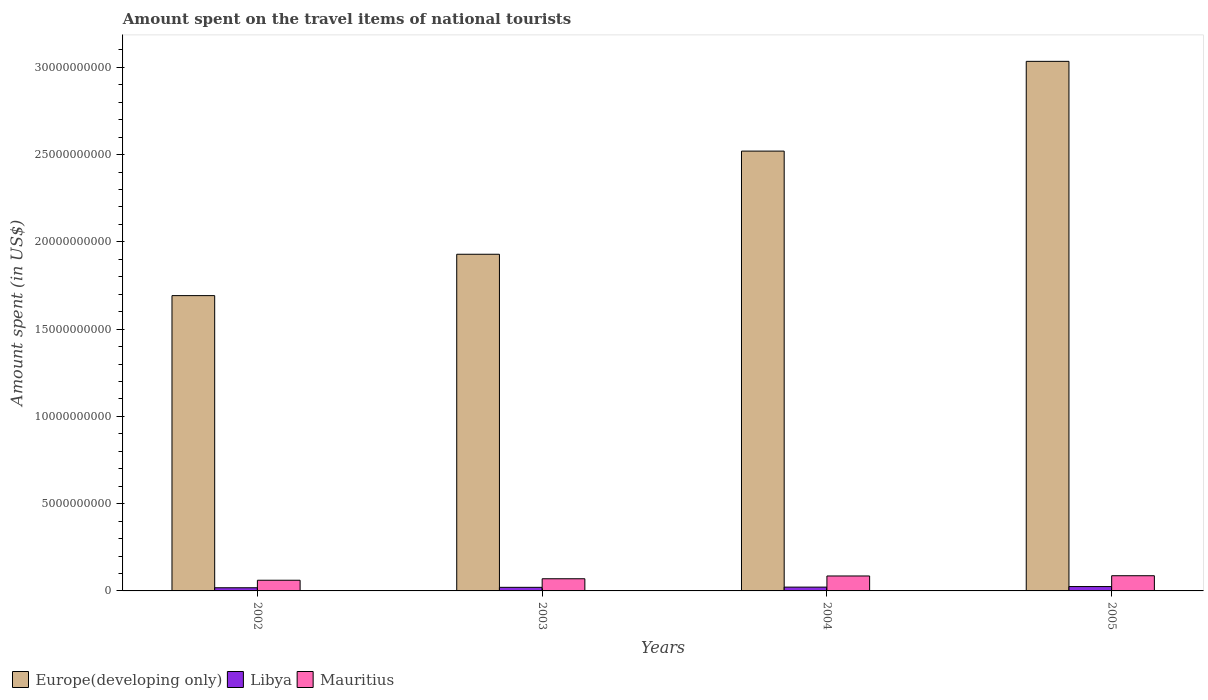How many different coloured bars are there?
Provide a succinct answer. 3. How many groups of bars are there?
Your response must be concise. 4. How many bars are there on the 4th tick from the right?
Provide a succinct answer. 3. What is the label of the 4th group of bars from the left?
Your answer should be compact. 2005. In how many cases, is the number of bars for a given year not equal to the number of legend labels?
Provide a succinct answer. 0. What is the amount spent on the travel items of national tourists in Europe(developing only) in 2002?
Your response must be concise. 1.69e+1. Across all years, what is the maximum amount spent on the travel items of national tourists in Libya?
Your answer should be compact. 2.50e+08. Across all years, what is the minimum amount spent on the travel items of national tourists in Europe(developing only)?
Give a very brief answer. 1.69e+1. In which year was the amount spent on the travel items of national tourists in Europe(developing only) maximum?
Keep it short and to the point. 2005. What is the total amount spent on the travel items of national tourists in Libya in the graph?
Provide a succinct answer. 8.54e+08. What is the difference between the amount spent on the travel items of national tourists in Libya in 2002 and that in 2003?
Offer a terse response. -2.40e+07. What is the difference between the amount spent on the travel items of national tourists in Libya in 2003 and the amount spent on the travel items of national tourists in Europe(developing only) in 2005?
Your answer should be compact. -3.01e+1. What is the average amount spent on the travel items of national tourists in Mauritius per year?
Provide a short and direct response. 7.59e+08. In the year 2003, what is the difference between the amount spent on the travel items of national tourists in Mauritius and amount spent on the travel items of national tourists in Libya?
Make the answer very short. 4.92e+08. What is the ratio of the amount spent on the travel items of national tourists in Libya in 2003 to that in 2005?
Keep it short and to the point. 0.82. Is the amount spent on the travel items of national tourists in Mauritius in 2003 less than that in 2004?
Provide a short and direct response. Yes. Is the difference between the amount spent on the travel items of national tourists in Mauritius in 2002 and 2005 greater than the difference between the amount spent on the travel items of national tourists in Libya in 2002 and 2005?
Your response must be concise. No. What is the difference between the highest and the second highest amount spent on the travel items of national tourists in Mauritius?
Provide a succinct answer. 1.50e+07. What is the difference between the highest and the lowest amount spent on the travel items of national tourists in Europe(developing only)?
Give a very brief answer. 1.34e+1. In how many years, is the amount spent on the travel items of national tourists in Mauritius greater than the average amount spent on the travel items of national tourists in Mauritius taken over all years?
Provide a succinct answer. 2. What does the 1st bar from the left in 2004 represents?
Offer a terse response. Europe(developing only). What does the 3rd bar from the right in 2002 represents?
Make the answer very short. Europe(developing only). Is it the case that in every year, the sum of the amount spent on the travel items of national tourists in Mauritius and amount spent on the travel items of national tourists in Libya is greater than the amount spent on the travel items of national tourists in Europe(developing only)?
Offer a terse response. No. How many bars are there?
Ensure brevity in your answer.  12. How many years are there in the graph?
Your answer should be compact. 4. Are the values on the major ticks of Y-axis written in scientific E-notation?
Offer a terse response. No. How many legend labels are there?
Offer a very short reply. 3. What is the title of the graph?
Ensure brevity in your answer.  Amount spent on the travel items of national tourists. What is the label or title of the X-axis?
Your response must be concise. Years. What is the label or title of the Y-axis?
Offer a terse response. Amount spent (in US$). What is the Amount spent (in US$) in Europe(developing only) in 2002?
Provide a succinct answer. 1.69e+1. What is the Amount spent (in US$) of Libya in 2002?
Provide a short and direct response. 1.81e+08. What is the Amount spent (in US$) in Mauritius in 2002?
Ensure brevity in your answer.  6.12e+08. What is the Amount spent (in US$) in Europe(developing only) in 2003?
Your response must be concise. 1.93e+1. What is the Amount spent (in US$) of Libya in 2003?
Give a very brief answer. 2.05e+08. What is the Amount spent (in US$) of Mauritius in 2003?
Offer a very short reply. 6.97e+08. What is the Amount spent (in US$) of Europe(developing only) in 2004?
Keep it short and to the point. 2.52e+1. What is the Amount spent (in US$) in Libya in 2004?
Offer a terse response. 2.18e+08. What is the Amount spent (in US$) in Mauritius in 2004?
Make the answer very short. 8.56e+08. What is the Amount spent (in US$) in Europe(developing only) in 2005?
Provide a succinct answer. 3.03e+1. What is the Amount spent (in US$) in Libya in 2005?
Give a very brief answer. 2.50e+08. What is the Amount spent (in US$) in Mauritius in 2005?
Ensure brevity in your answer.  8.71e+08. Across all years, what is the maximum Amount spent (in US$) in Europe(developing only)?
Offer a very short reply. 3.03e+1. Across all years, what is the maximum Amount spent (in US$) in Libya?
Offer a terse response. 2.50e+08. Across all years, what is the maximum Amount spent (in US$) of Mauritius?
Offer a very short reply. 8.71e+08. Across all years, what is the minimum Amount spent (in US$) of Europe(developing only)?
Your response must be concise. 1.69e+1. Across all years, what is the minimum Amount spent (in US$) in Libya?
Make the answer very short. 1.81e+08. Across all years, what is the minimum Amount spent (in US$) of Mauritius?
Provide a short and direct response. 6.12e+08. What is the total Amount spent (in US$) of Europe(developing only) in the graph?
Provide a succinct answer. 9.18e+1. What is the total Amount spent (in US$) of Libya in the graph?
Give a very brief answer. 8.54e+08. What is the total Amount spent (in US$) in Mauritius in the graph?
Offer a terse response. 3.04e+09. What is the difference between the Amount spent (in US$) of Europe(developing only) in 2002 and that in 2003?
Give a very brief answer. -2.37e+09. What is the difference between the Amount spent (in US$) in Libya in 2002 and that in 2003?
Provide a succinct answer. -2.40e+07. What is the difference between the Amount spent (in US$) in Mauritius in 2002 and that in 2003?
Provide a succinct answer. -8.50e+07. What is the difference between the Amount spent (in US$) in Europe(developing only) in 2002 and that in 2004?
Ensure brevity in your answer.  -8.28e+09. What is the difference between the Amount spent (in US$) in Libya in 2002 and that in 2004?
Ensure brevity in your answer.  -3.70e+07. What is the difference between the Amount spent (in US$) in Mauritius in 2002 and that in 2004?
Ensure brevity in your answer.  -2.44e+08. What is the difference between the Amount spent (in US$) in Europe(developing only) in 2002 and that in 2005?
Provide a short and direct response. -1.34e+1. What is the difference between the Amount spent (in US$) of Libya in 2002 and that in 2005?
Your response must be concise. -6.90e+07. What is the difference between the Amount spent (in US$) of Mauritius in 2002 and that in 2005?
Give a very brief answer. -2.59e+08. What is the difference between the Amount spent (in US$) of Europe(developing only) in 2003 and that in 2004?
Give a very brief answer. -5.91e+09. What is the difference between the Amount spent (in US$) of Libya in 2003 and that in 2004?
Offer a terse response. -1.30e+07. What is the difference between the Amount spent (in US$) in Mauritius in 2003 and that in 2004?
Provide a short and direct response. -1.59e+08. What is the difference between the Amount spent (in US$) in Europe(developing only) in 2003 and that in 2005?
Make the answer very short. -1.11e+1. What is the difference between the Amount spent (in US$) in Libya in 2003 and that in 2005?
Offer a very short reply. -4.50e+07. What is the difference between the Amount spent (in US$) in Mauritius in 2003 and that in 2005?
Provide a short and direct response. -1.74e+08. What is the difference between the Amount spent (in US$) in Europe(developing only) in 2004 and that in 2005?
Provide a short and direct response. -5.14e+09. What is the difference between the Amount spent (in US$) in Libya in 2004 and that in 2005?
Keep it short and to the point. -3.20e+07. What is the difference between the Amount spent (in US$) of Mauritius in 2004 and that in 2005?
Your answer should be compact. -1.50e+07. What is the difference between the Amount spent (in US$) of Europe(developing only) in 2002 and the Amount spent (in US$) of Libya in 2003?
Make the answer very short. 1.67e+1. What is the difference between the Amount spent (in US$) of Europe(developing only) in 2002 and the Amount spent (in US$) of Mauritius in 2003?
Provide a succinct answer. 1.62e+1. What is the difference between the Amount spent (in US$) in Libya in 2002 and the Amount spent (in US$) in Mauritius in 2003?
Offer a terse response. -5.16e+08. What is the difference between the Amount spent (in US$) of Europe(developing only) in 2002 and the Amount spent (in US$) of Libya in 2004?
Your response must be concise. 1.67e+1. What is the difference between the Amount spent (in US$) in Europe(developing only) in 2002 and the Amount spent (in US$) in Mauritius in 2004?
Ensure brevity in your answer.  1.61e+1. What is the difference between the Amount spent (in US$) in Libya in 2002 and the Amount spent (in US$) in Mauritius in 2004?
Offer a terse response. -6.75e+08. What is the difference between the Amount spent (in US$) in Europe(developing only) in 2002 and the Amount spent (in US$) in Libya in 2005?
Give a very brief answer. 1.67e+1. What is the difference between the Amount spent (in US$) in Europe(developing only) in 2002 and the Amount spent (in US$) in Mauritius in 2005?
Make the answer very short. 1.60e+1. What is the difference between the Amount spent (in US$) in Libya in 2002 and the Amount spent (in US$) in Mauritius in 2005?
Your answer should be very brief. -6.90e+08. What is the difference between the Amount spent (in US$) of Europe(developing only) in 2003 and the Amount spent (in US$) of Libya in 2004?
Your response must be concise. 1.91e+1. What is the difference between the Amount spent (in US$) of Europe(developing only) in 2003 and the Amount spent (in US$) of Mauritius in 2004?
Make the answer very short. 1.84e+1. What is the difference between the Amount spent (in US$) of Libya in 2003 and the Amount spent (in US$) of Mauritius in 2004?
Provide a short and direct response. -6.51e+08. What is the difference between the Amount spent (in US$) of Europe(developing only) in 2003 and the Amount spent (in US$) of Libya in 2005?
Offer a terse response. 1.90e+1. What is the difference between the Amount spent (in US$) in Europe(developing only) in 2003 and the Amount spent (in US$) in Mauritius in 2005?
Offer a terse response. 1.84e+1. What is the difference between the Amount spent (in US$) in Libya in 2003 and the Amount spent (in US$) in Mauritius in 2005?
Your answer should be very brief. -6.66e+08. What is the difference between the Amount spent (in US$) in Europe(developing only) in 2004 and the Amount spent (in US$) in Libya in 2005?
Your answer should be compact. 2.49e+1. What is the difference between the Amount spent (in US$) of Europe(developing only) in 2004 and the Amount spent (in US$) of Mauritius in 2005?
Give a very brief answer. 2.43e+1. What is the difference between the Amount spent (in US$) in Libya in 2004 and the Amount spent (in US$) in Mauritius in 2005?
Give a very brief answer. -6.53e+08. What is the average Amount spent (in US$) of Europe(developing only) per year?
Provide a short and direct response. 2.29e+1. What is the average Amount spent (in US$) in Libya per year?
Offer a terse response. 2.14e+08. What is the average Amount spent (in US$) in Mauritius per year?
Offer a terse response. 7.59e+08. In the year 2002, what is the difference between the Amount spent (in US$) in Europe(developing only) and Amount spent (in US$) in Libya?
Offer a very short reply. 1.67e+1. In the year 2002, what is the difference between the Amount spent (in US$) in Europe(developing only) and Amount spent (in US$) in Mauritius?
Ensure brevity in your answer.  1.63e+1. In the year 2002, what is the difference between the Amount spent (in US$) of Libya and Amount spent (in US$) of Mauritius?
Ensure brevity in your answer.  -4.31e+08. In the year 2003, what is the difference between the Amount spent (in US$) in Europe(developing only) and Amount spent (in US$) in Libya?
Provide a short and direct response. 1.91e+1. In the year 2003, what is the difference between the Amount spent (in US$) in Europe(developing only) and Amount spent (in US$) in Mauritius?
Provide a short and direct response. 1.86e+1. In the year 2003, what is the difference between the Amount spent (in US$) of Libya and Amount spent (in US$) of Mauritius?
Your answer should be very brief. -4.92e+08. In the year 2004, what is the difference between the Amount spent (in US$) in Europe(developing only) and Amount spent (in US$) in Libya?
Your response must be concise. 2.50e+1. In the year 2004, what is the difference between the Amount spent (in US$) of Europe(developing only) and Amount spent (in US$) of Mauritius?
Ensure brevity in your answer.  2.43e+1. In the year 2004, what is the difference between the Amount spent (in US$) in Libya and Amount spent (in US$) in Mauritius?
Give a very brief answer. -6.38e+08. In the year 2005, what is the difference between the Amount spent (in US$) of Europe(developing only) and Amount spent (in US$) of Libya?
Give a very brief answer. 3.01e+1. In the year 2005, what is the difference between the Amount spent (in US$) in Europe(developing only) and Amount spent (in US$) in Mauritius?
Offer a terse response. 2.95e+1. In the year 2005, what is the difference between the Amount spent (in US$) in Libya and Amount spent (in US$) in Mauritius?
Your answer should be very brief. -6.21e+08. What is the ratio of the Amount spent (in US$) of Europe(developing only) in 2002 to that in 2003?
Your answer should be very brief. 0.88. What is the ratio of the Amount spent (in US$) in Libya in 2002 to that in 2003?
Your answer should be very brief. 0.88. What is the ratio of the Amount spent (in US$) of Mauritius in 2002 to that in 2003?
Offer a terse response. 0.88. What is the ratio of the Amount spent (in US$) of Europe(developing only) in 2002 to that in 2004?
Your answer should be compact. 0.67. What is the ratio of the Amount spent (in US$) of Libya in 2002 to that in 2004?
Offer a very short reply. 0.83. What is the ratio of the Amount spent (in US$) in Mauritius in 2002 to that in 2004?
Your answer should be compact. 0.71. What is the ratio of the Amount spent (in US$) in Europe(developing only) in 2002 to that in 2005?
Your answer should be compact. 0.56. What is the ratio of the Amount spent (in US$) of Libya in 2002 to that in 2005?
Give a very brief answer. 0.72. What is the ratio of the Amount spent (in US$) of Mauritius in 2002 to that in 2005?
Offer a terse response. 0.7. What is the ratio of the Amount spent (in US$) of Europe(developing only) in 2003 to that in 2004?
Keep it short and to the point. 0.77. What is the ratio of the Amount spent (in US$) in Libya in 2003 to that in 2004?
Give a very brief answer. 0.94. What is the ratio of the Amount spent (in US$) of Mauritius in 2003 to that in 2004?
Make the answer very short. 0.81. What is the ratio of the Amount spent (in US$) of Europe(developing only) in 2003 to that in 2005?
Your answer should be very brief. 0.64. What is the ratio of the Amount spent (in US$) of Libya in 2003 to that in 2005?
Your answer should be very brief. 0.82. What is the ratio of the Amount spent (in US$) of Mauritius in 2003 to that in 2005?
Offer a terse response. 0.8. What is the ratio of the Amount spent (in US$) of Europe(developing only) in 2004 to that in 2005?
Make the answer very short. 0.83. What is the ratio of the Amount spent (in US$) in Libya in 2004 to that in 2005?
Offer a terse response. 0.87. What is the ratio of the Amount spent (in US$) of Mauritius in 2004 to that in 2005?
Keep it short and to the point. 0.98. What is the difference between the highest and the second highest Amount spent (in US$) in Europe(developing only)?
Keep it short and to the point. 5.14e+09. What is the difference between the highest and the second highest Amount spent (in US$) of Libya?
Offer a very short reply. 3.20e+07. What is the difference between the highest and the second highest Amount spent (in US$) in Mauritius?
Your answer should be compact. 1.50e+07. What is the difference between the highest and the lowest Amount spent (in US$) in Europe(developing only)?
Your answer should be very brief. 1.34e+1. What is the difference between the highest and the lowest Amount spent (in US$) of Libya?
Ensure brevity in your answer.  6.90e+07. What is the difference between the highest and the lowest Amount spent (in US$) in Mauritius?
Ensure brevity in your answer.  2.59e+08. 